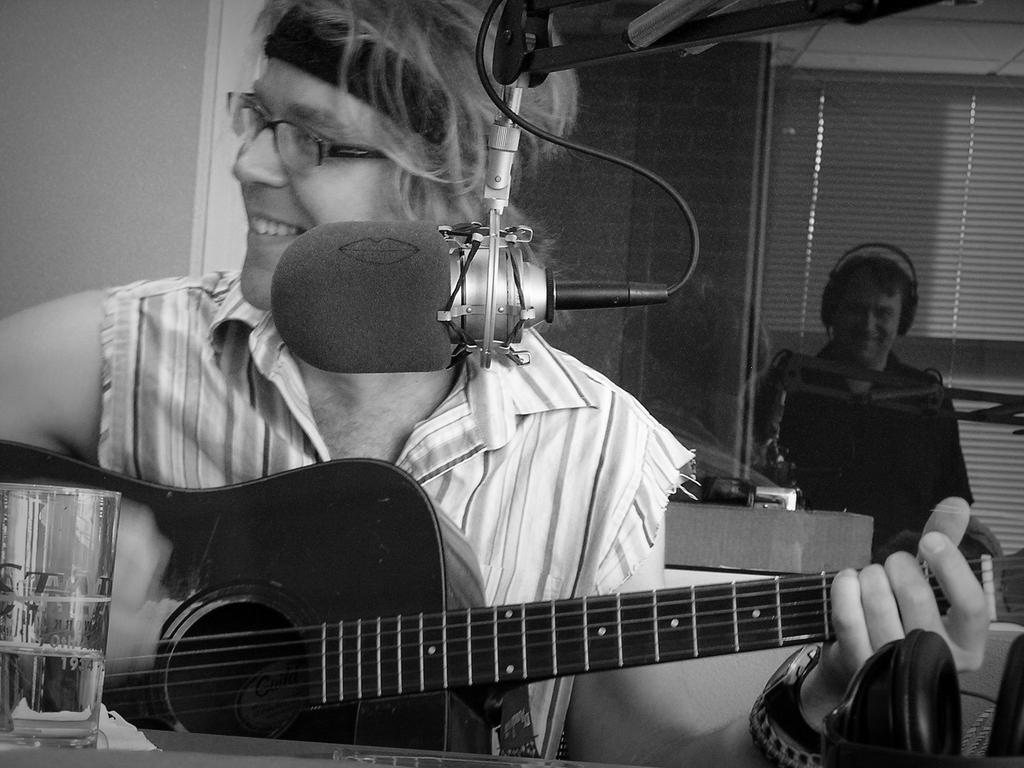What is the man in the image doing? The man is playing a guitar. What object is in front of the man? There is a microphone in front of the man. How many trucks are visible in the image? There are no trucks present in the image. Where is the faucet located in the image? There is no faucet present in the image. 